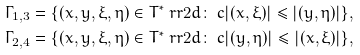Convert formula to latex. <formula><loc_0><loc_0><loc_500><loc_500>\Gamma _ { 1 , 3 } & = \{ ( x , y , \xi , \eta ) \in T ^ { * } \ r r { 2 d } \colon \ c | ( x , \xi ) | \leqslant | ( y , \eta ) | \} , \\ \Gamma _ { 2 , 4 } & = \{ ( x , y , \xi , \eta ) \in T ^ { * } \ r r { 2 d } \colon \ c | ( y , \eta ) | \leqslant | ( x , \xi ) | \} , \\</formula> 